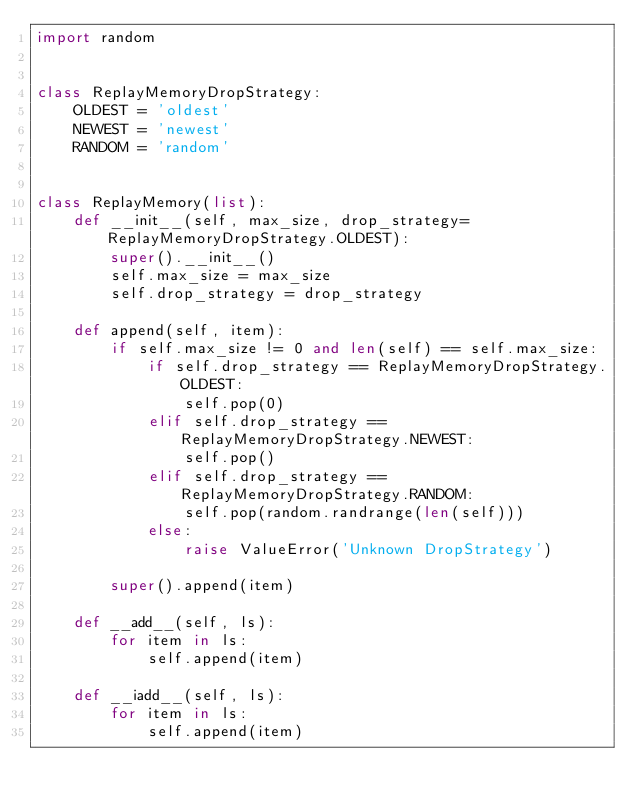<code> <loc_0><loc_0><loc_500><loc_500><_Python_>import random


class ReplayMemoryDropStrategy:
    OLDEST = 'oldest'
    NEWEST = 'newest'
    RANDOM = 'random'


class ReplayMemory(list):
    def __init__(self, max_size, drop_strategy=ReplayMemoryDropStrategy.OLDEST):
        super().__init__()
        self.max_size = max_size
        self.drop_strategy = drop_strategy

    def append(self, item):
        if self.max_size != 0 and len(self) == self.max_size:
            if self.drop_strategy == ReplayMemoryDropStrategy.OLDEST:
                self.pop(0)
            elif self.drop_strategy == ReplayMemoryDropStrategy.NEWEST:
                self.pop()
            elif self.drop_strategy == ReplayMemoryDropStrategy.RANDOM:
                self.pop(random.randrange(len(self)))
            else:
                raise ValueError('Unknown DropStrategy')

        super().append(item)

    def __add__(self, ls):
        for item in ls:
            self.append(item)

    def __iadd__(self, ls):
        for item in ls:
            self.append(item)
</code> 